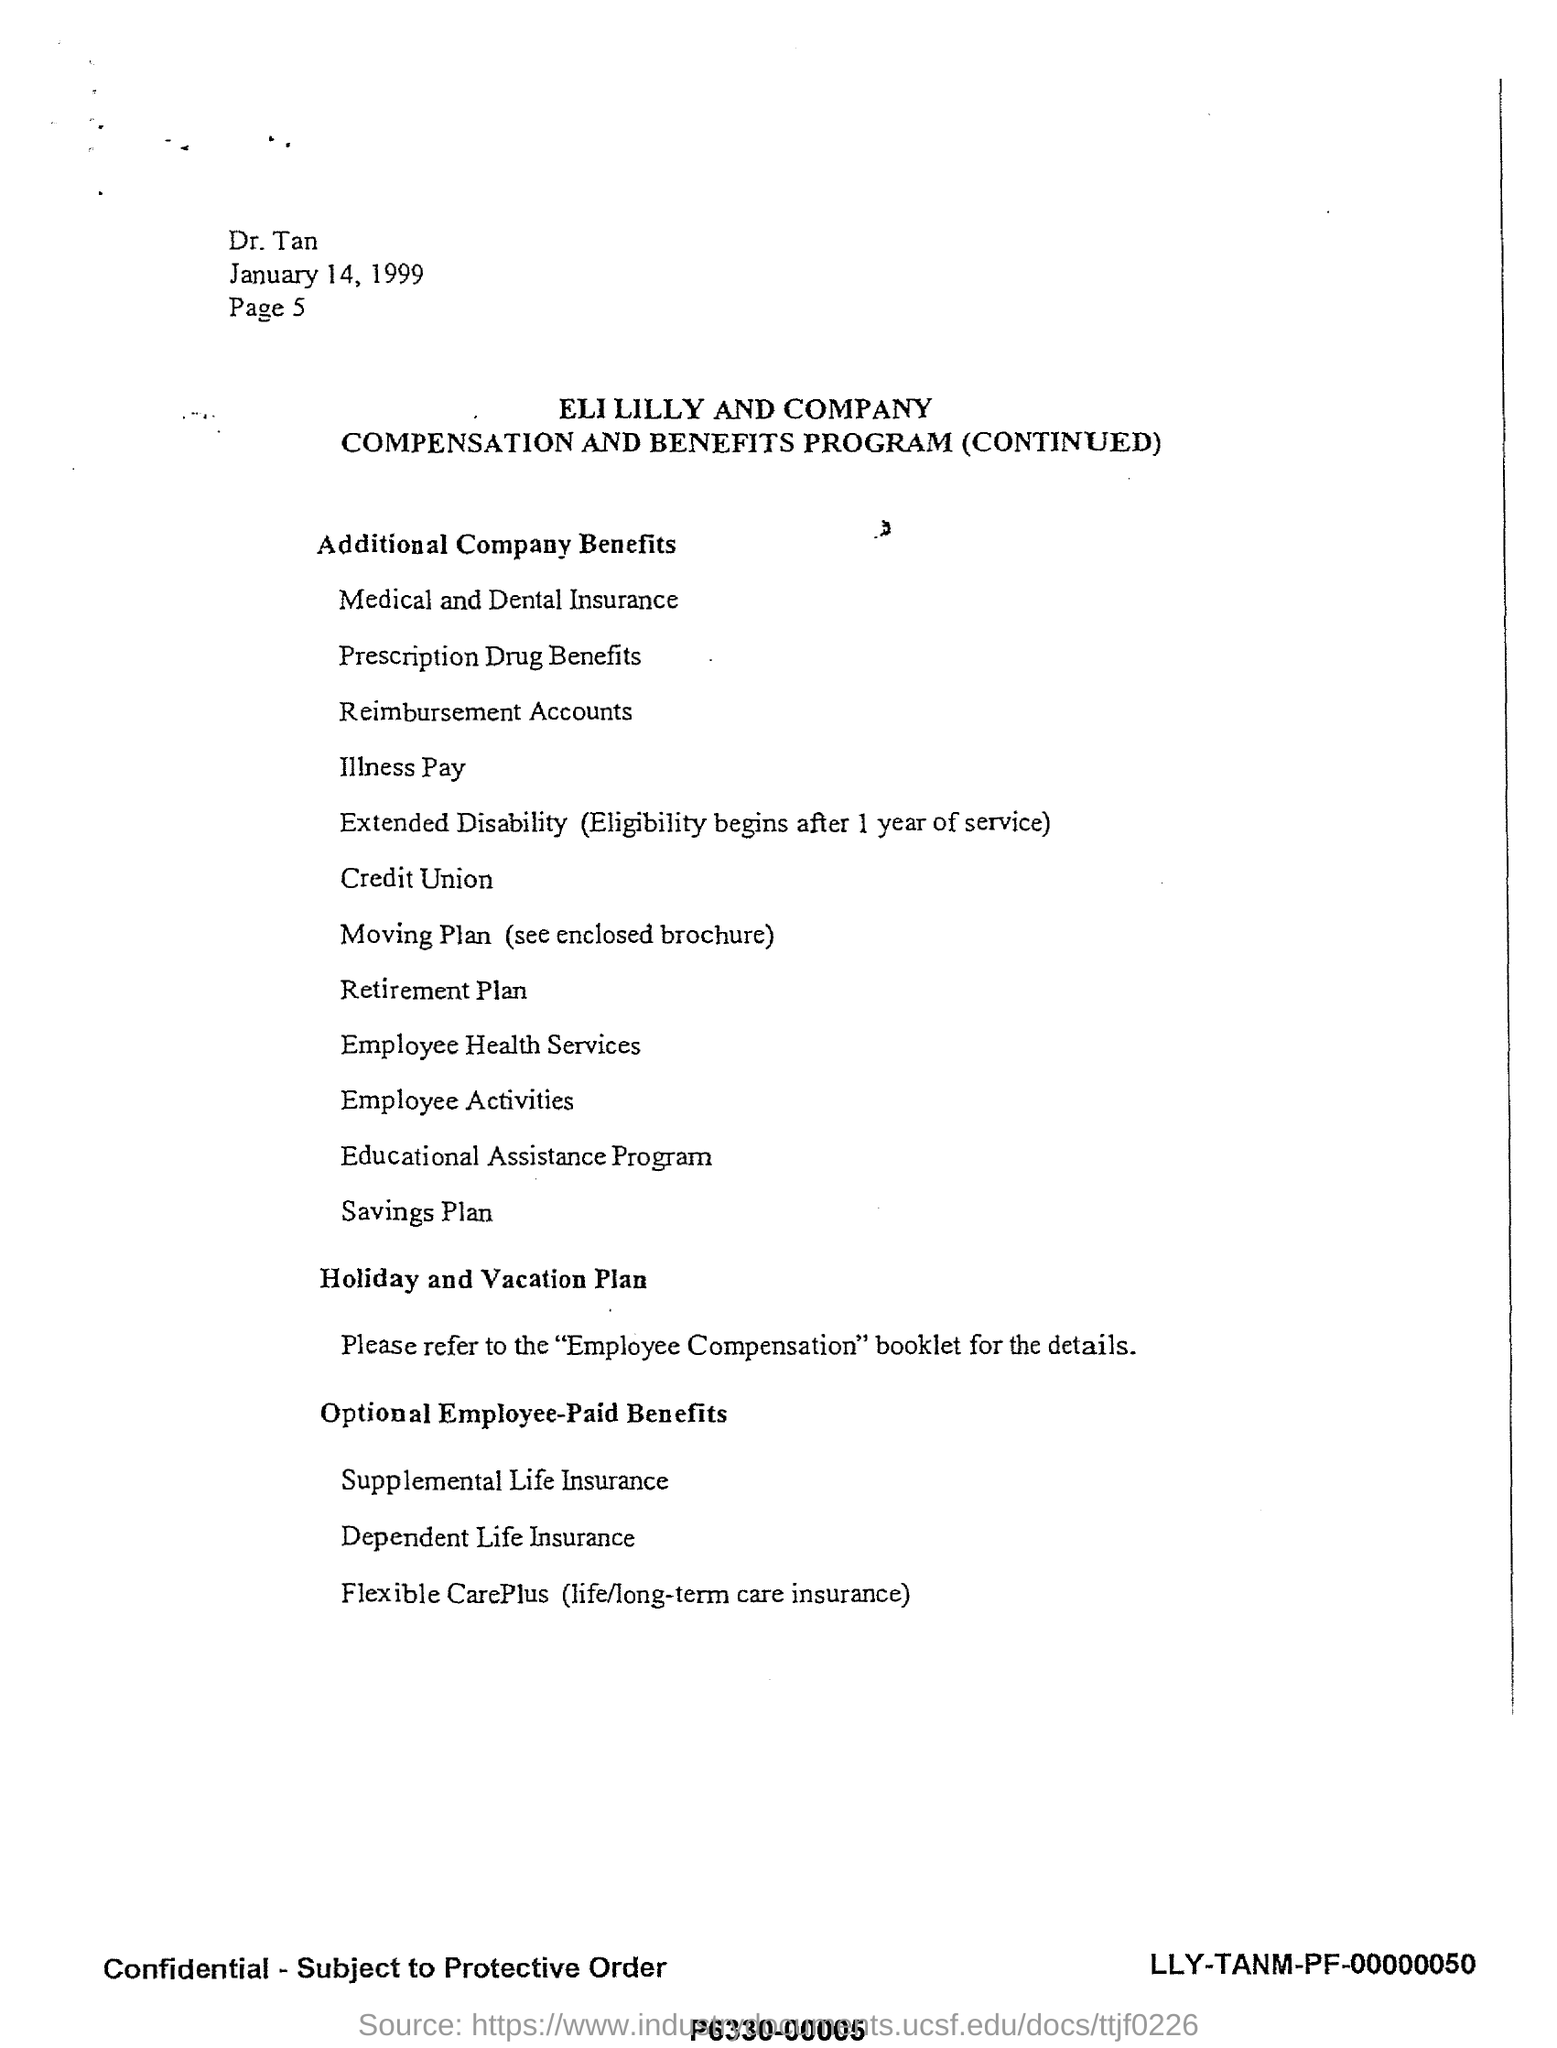What is the date mentioned?
Keep it short and to the point. January 14, 1999. What is the company name ?
Offer a very short reply. ELI LILLY AND COMPANY. Which benefit start after 1 year of service?
Give a very brief answer. Extended Disability. 